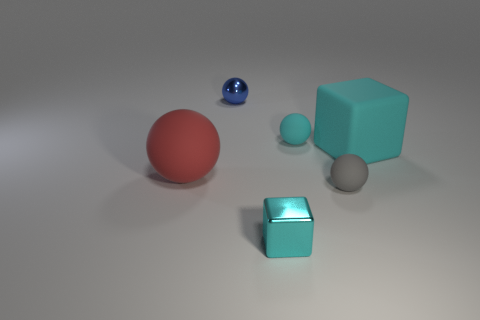Subtract all purple balls. Subtract all green blocks. How many balls are left? 4 Add 4 big gray rubber things. How many objects exist? 10 Subtract all cubes. How many objects are left? 4 Add 6 tiny metallic spheres. How many tiny metallic spheres are left? 7 Add 6 tiny blue shiny balls. How many tiny blue shiny balls exist? 7 Subtract 0 gray cubes. How many objects are left? 6 Subtract all large purple rubber cylinders. Subtract all large matte balls. How many objects are left? 5 